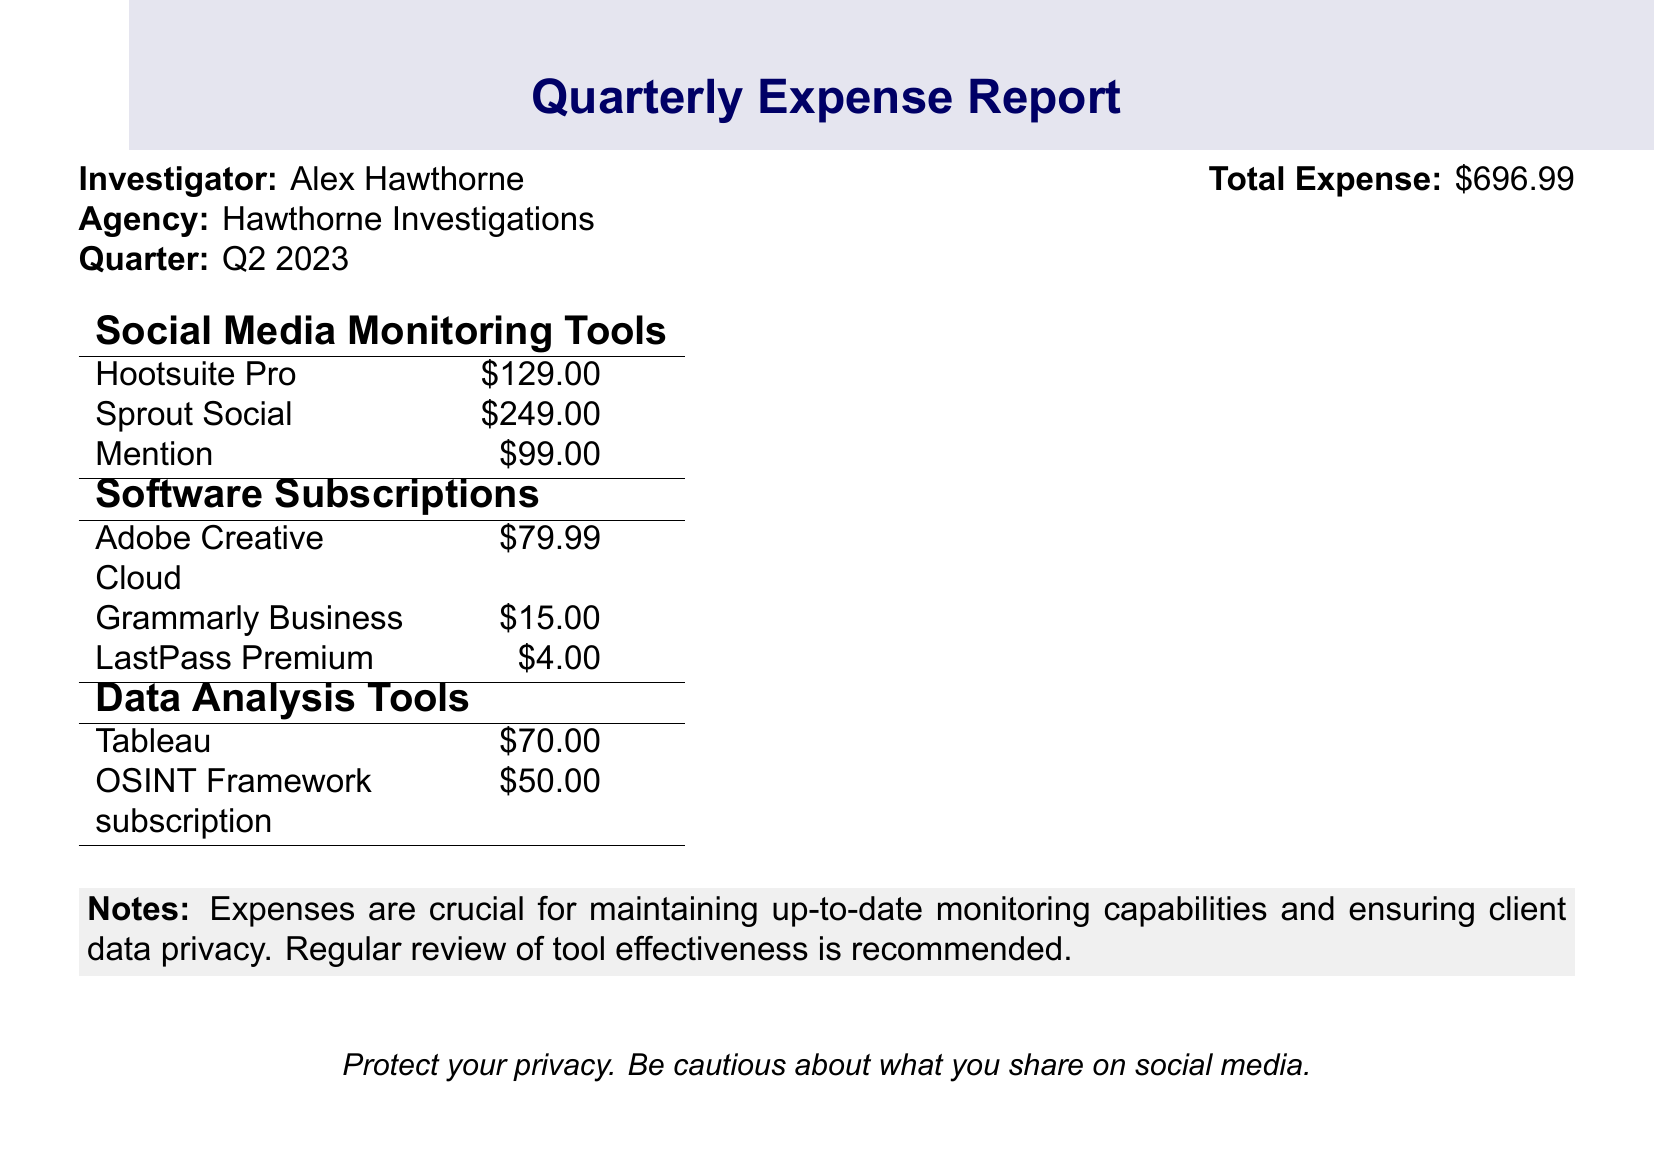What is the total expense? The total expense is stated at the top of the document as the overall amount spent in the quarter.
Answer: $696.99 How much did Hootsuite Pro cost? Hootsuite Pro is listed under Social Media Monitoring Tools with its specific expense amount.
Answer: $129.00 What is the expense for Sprout Social? Sprout Social is another tool listed with its own expense amount within the document.
Answer: $249.00 How many social media monitoring tools are listed? The document provides a section specifically for Social Media Monitoring Tools, listing individual tools by name.
Answer: 3 What is the total expense for software subscriptions? Software subscriptions expenses are detailed in a specific section of the document, calculated from individual amounts.
Answer: $98.99 What is the cost of Grammarly Business? Grammarly Business is listed with its expense in the Software Subscriptions section.
Answer: $15.00 Is there a note on privacy? The document includes a section that comments on the importance of privacy in social media sharing.
Answer: Yes What is the cost of Tableau? Tableau's expense is specified under the Data Analysis Tools section in the document.
Answer: $70.00 What is the quarter being reported? The quarter is mentioned at the top of the document along with the investigator's details.
Answer: Q2 2023 